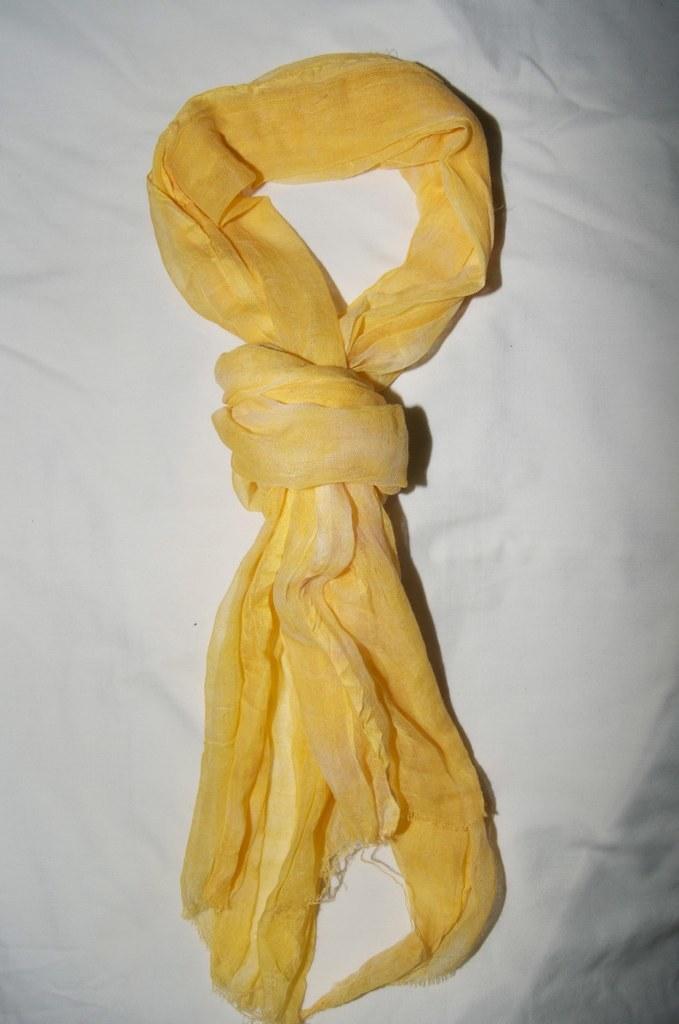Could you give a brief overview of what you see in this image? This image consists of a cloth in yellow color. At the bottom, it looks like a bed which is covered with a white cloth. 